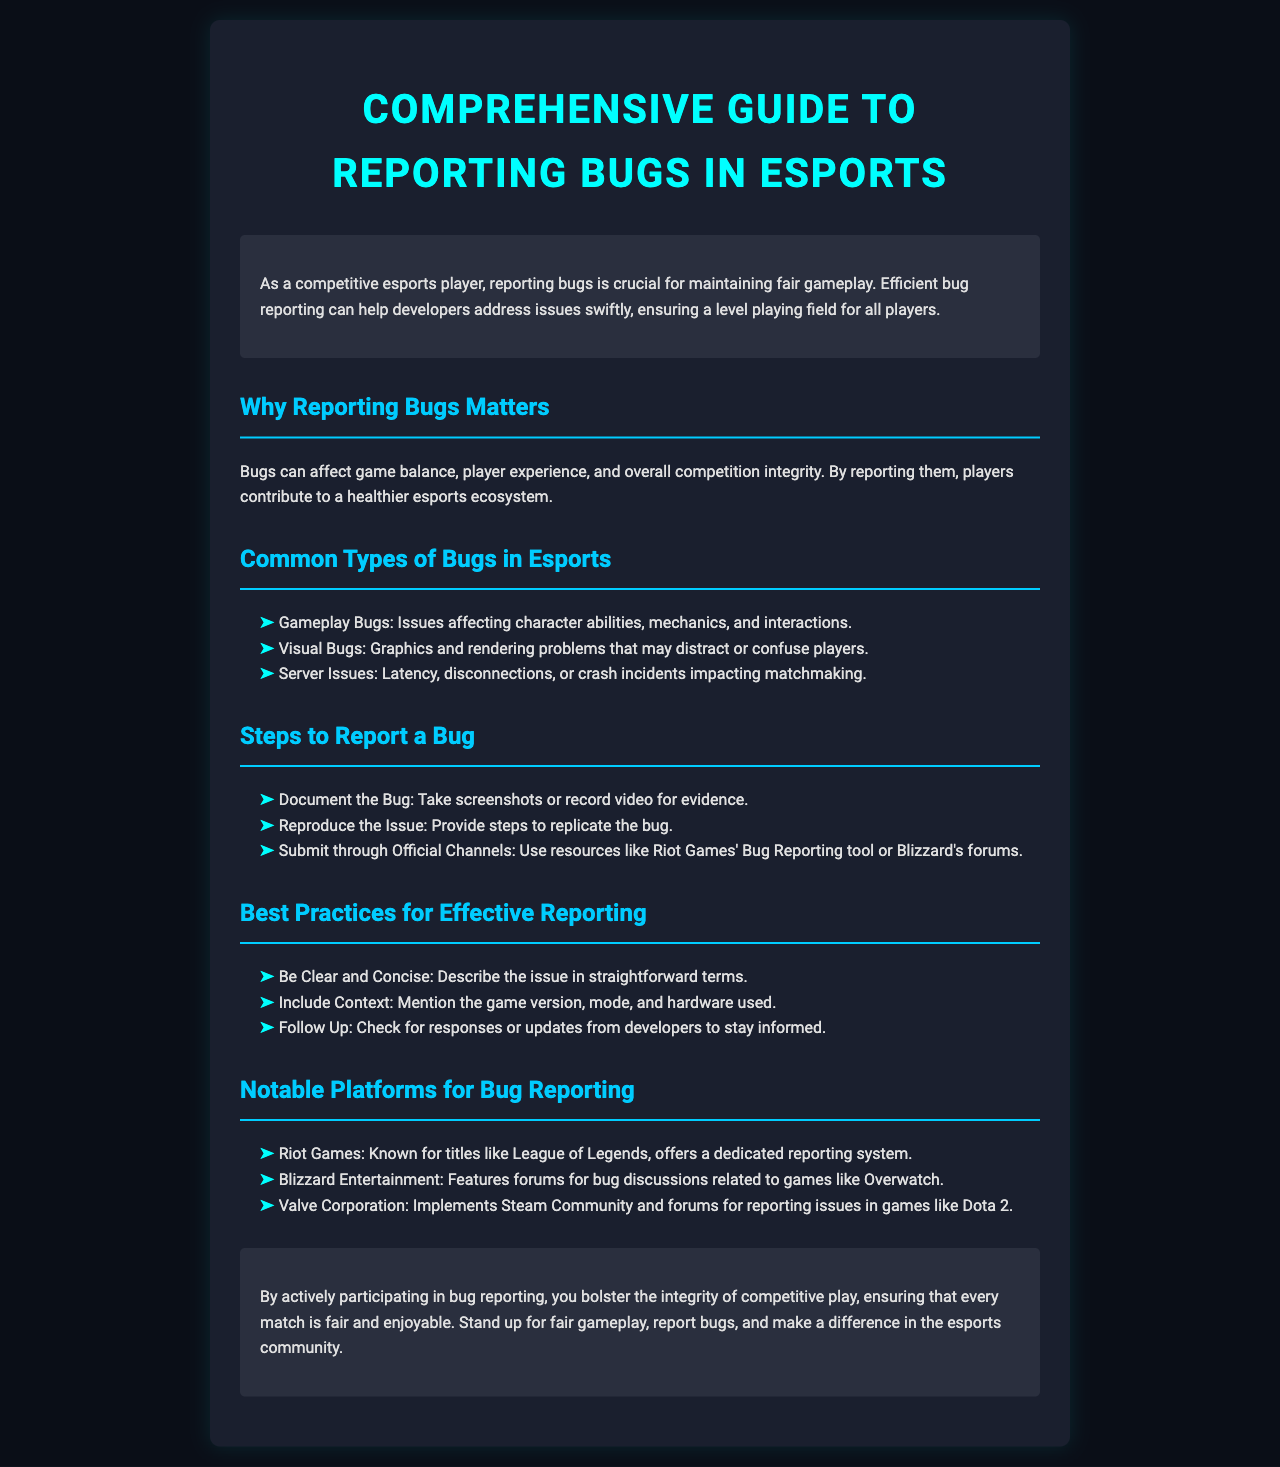what is the title of the document? The title of the document is stated at the top of the rendered brochure.
Answer: Comprehensive Guide to Reporting Bugs in Esports what is one common type of bug in esports? Among the listed types, this information can be found in the "Common Types of Bugs in Esports" section.
Answer: Gameplay Bugs what should you do first when reporting a bug? The steps provided in the "Steps to Report a Bug" section indicate the initial action to take.
Answer: Document the Bug which company is known for League of Legends? The section on notable platforms for bug reporting specifies companies alongside their main titles.
Answer: Riot Games how many steps are outlined for reporting a bug? The document lists three specific steps under the "Steps to Report a Bug" section.
Answer: 3 what color is used for subheadings in the document? The style rules and rendered colors can be observed in the h2 headings throughout the brochure.
Answer: #00ccff what is the purpose of the introduction? The introductory paragraph describes the significance of reporting bugs for competitive players.
Answer: To maintain fair gameplay what is a best practice for effective reporting? The "Best Practices for Effective Reporting" section lists multiple recommendations for players.
Answer: Be Clear and Concise which game company uses forums for bug discussions? The document specifically names the company in relation to its forum use for bug reporting.
Answer: Blizzard Entertainment 